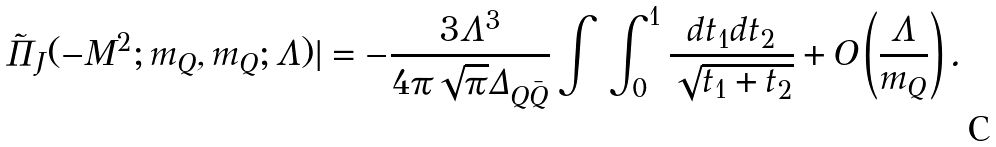<formula> <loc_0><loc_0><loc_500><loc_500>\tilde { \Pi } _ { J } ( - M ^ { 2 } ; m _ { Q } , m _ { Q } ; \Lambda ) | = - \frac { 3 \Lambda ^ { 3 } } { 4 \pi \sqrt { \pi } \Delta _ { Q \bar { Q } } } \int \, \int _ { 0 } ^ { 1 } \frac { d t _ { 1 } d t _ { 2 } } { \sqrt { t _ { 1 } + t _ { 2 } } } + O \left ( \frac { \Lambda } { m _ { Q } } \right ) .</formula> 